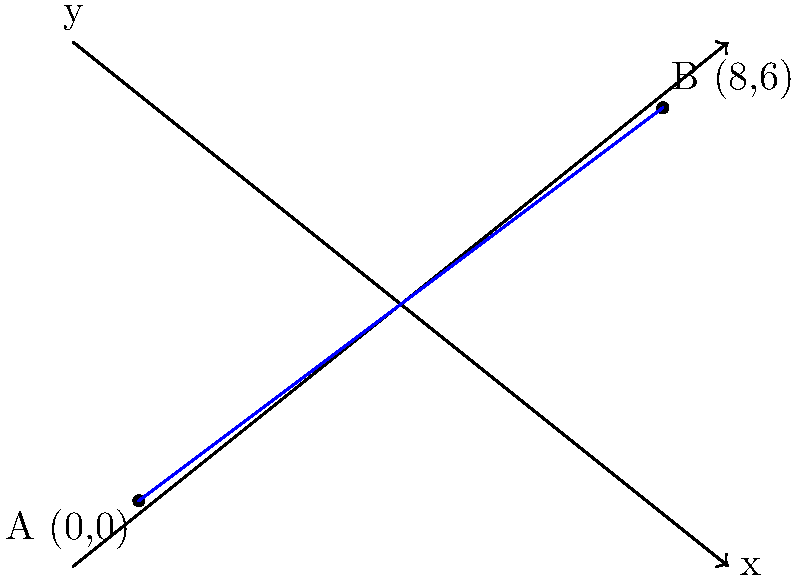In a new Nollywood film production, two key scenes are to be shot at different locations in Lagos. The film's female director, a role model in the industry, is planning the logistics. She represents the locations on a coordinate grid, where each unit represents 1 km. The first location (A) is at the origin (0,0), and the second location (B) is at (8,6). What is the straight-line distance between these two filming locations? To find the straight-line distance between two points, we can use the distance formula, which is derived from the Pythagorean theorem:

$$d = \sqrt{(x_2 - x_1)^2 + (y_2 - y_1)^2}$$

Where $(x_1, y_1)$ represents the coordinates of the first point and $(x_2, y_2)$ represents the coordinates of the second point.

Given:
- Point A: $(x_1, y_1) = (0, 0)$
- Point B: $(x_2, y_2) = (8, 6)$

Let's substitute these values into the formula:

$$d = \sqrt{(8 - 0)^2 + (6 - 0)^2}$$

Simplify:
$$d = \sqrt{8^2 + 6^2}$$

Calculate the squares:
$$d = \sqrt{64 + 36}$$

Add under the square root:
$$d = \sqrt{100}$$

Simplify:
$$d = 10$$

Since each unit represents 1 km, the distance between the two filming locations is 10 km.
Answer: 10 km 